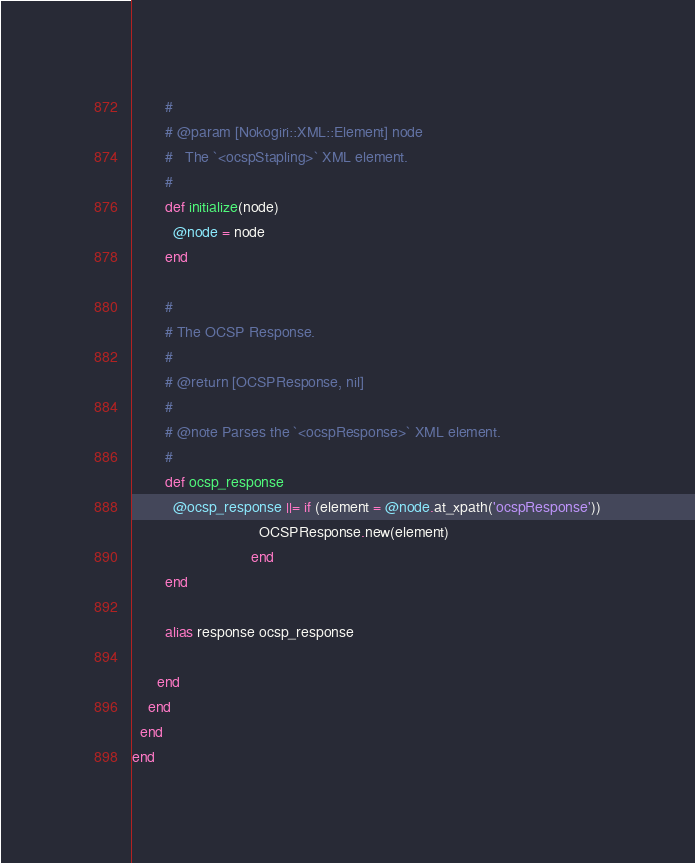<code> <loc_0><loc_0><loc_500><loc_500><_Ruby_>        #
        # @param [Nokogiri::XML::Element] node
        #   The `<ocspStapling>` XML element.
        #
        def initialize(node)
          @node = node
        end

        #
        # The OCSP Response.
        #
        # @return [OCSPResponse, nil]
        #
        # @note Parses the `<ocspResponse>` XML element.
        #
        def ocsp_response
          @ocsp_response ||= if (element = @node.at_xpath('ocspResponse'))
                               OCSPResponse.new(element)
                             end
        end

        alias response ocsp_response

      end
    end
  end
end
</code> 